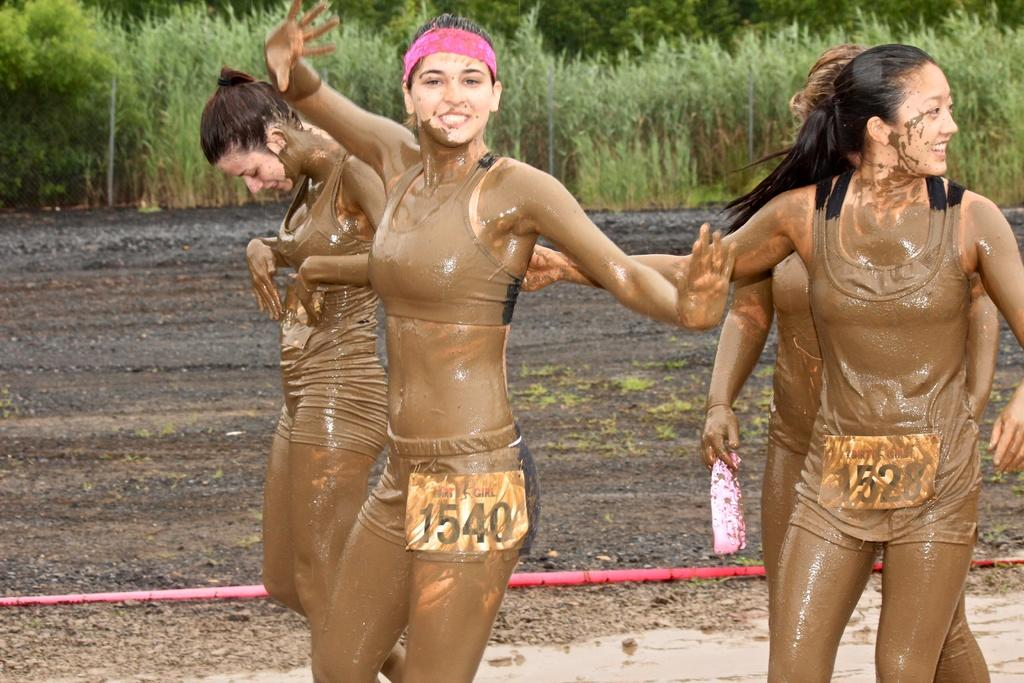What are the women in the image doing? The women in the image are in motion. What can be seen on the women's bodies? The women have stickers on them. What type of vegetation is visible in the background of the image? There are plants and trees in the background of the image. What type of board can be seen in the image? There is no board present in the image. How many geese are visible in the image? There are no geese visible in the image. 